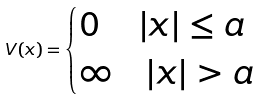Convert formula to latex. <formula><loc_0><loc_0><loc_500><loc_500>V ( x ) = \begin{cases} 0 \quad \, | x | \leq a \\ \infty \quad | x | > a \end{cases}</formula> 